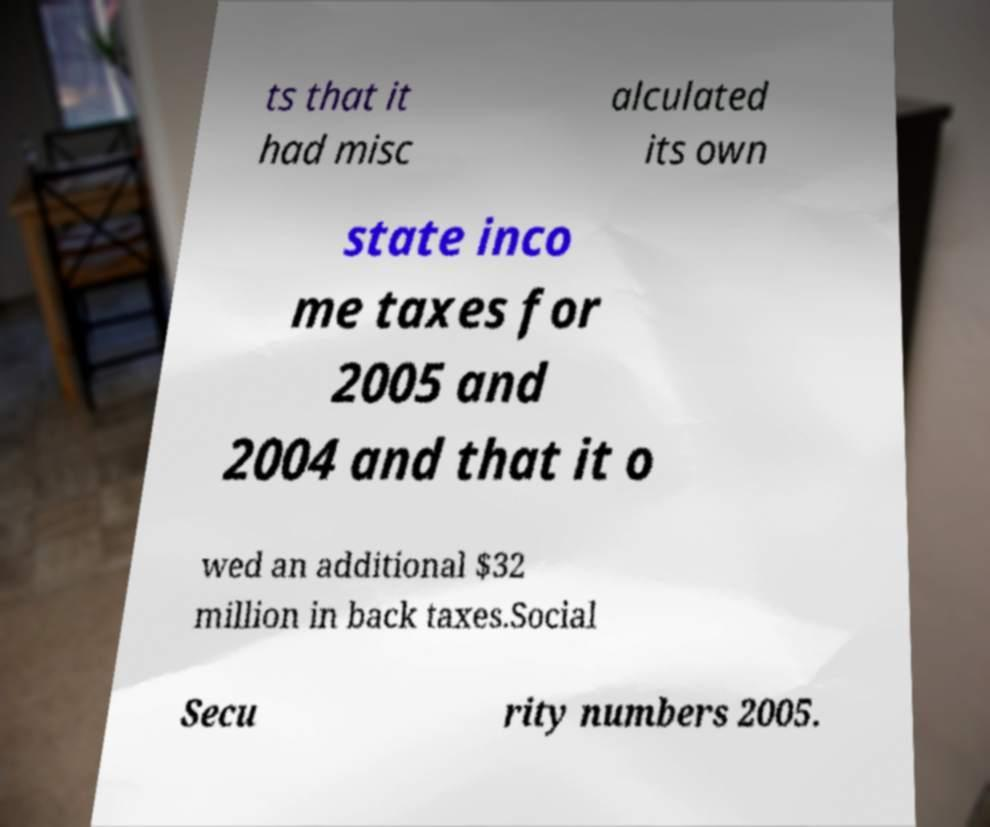Please read and relay the text visible in this image. What does it say? ts that it had misc alculated its own state inco me taxes for 2005 and 2004 and that it o wed an additional $32 million in back taxes.Social Secu rity numbers 2005. 